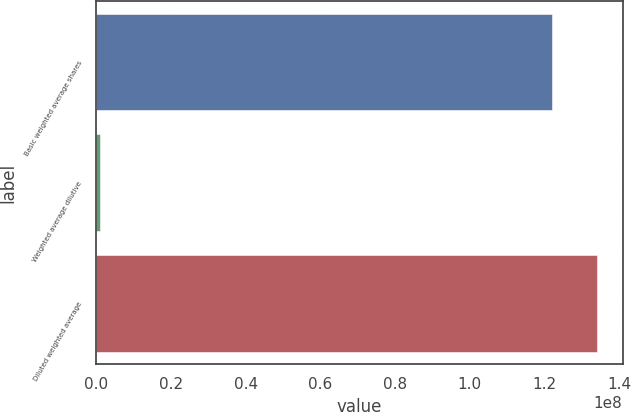<chart> <loc_0><loc_0><loc_500><loc_500><bar_chart><fcel>Basic weighted average shares<fcel>Weighted average dilutive<fcel>Diluted weighted average<nl><fcel>1.22009e+08<fcel>1.11411e+06<fcel>1.3421e+08<nl></chart> 